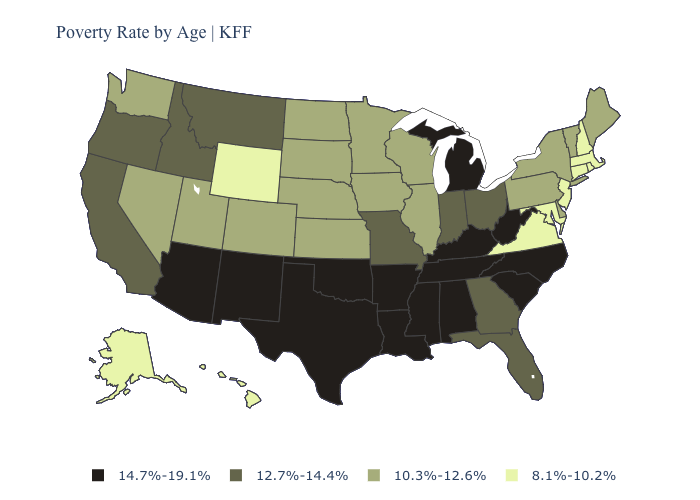Does Alaska have the highest value in the USA?
Be succinct. No. Name the states that have a value in the range 8.1%-10.2%?
Write a very short answer. Alaska, Connecticut, Hawaii, Maryland, Massachusetts, New Hampshire, New Jersey, Rhode Island, Virginia, Wyoming. Name the states that have a value in the range 8.1%-10.2%?
Write a very short answer. Alaska, Connecticut, Hawaii, Maryland, Massachusetts, New Hampshire, New Jersey, Rhode Island, Virginia, Wyoming. What is the highest value in the South ?
Give a very brief answer. 14.7%-19.1%. Does Wisconsin have a higher value than Arizona?
Short answer required. No. What is the value of Illinois?
Keep it brief. 10.3%-12.6%. Which states hav the highest value in the South?
Write a very short answer. Alabama, Arkansas, Kentucky, Louisiana, Mississippi, North Carolina, Oklahoma, South Carolina, Tennessee, Texas, West Virginia. Is the legend a continuous bar?
Be succinct. No. Does Hawaii have the same value as Maryland?
Concise answer only. Yes. Name the states that have a value in the range 8.1%-10.2%?
Give a very brief answer. Alaska, Connecticut, Hawaii, Maryland, Massachusetts, New Hampshire, New Jersey, Rhode Island, Virginia, Wyoming. What is the lowest value in the USA?
Be succinct. 8.1%-10.2%. Which states have the highest value in the USA?
Answer briefly. Alabama, Arizona, Arkansas, Kentucky, Louisiana, Michigan, Mississippi, New Mexico, North Carolina, Oklahoma, South Carolina, Tennessee, Texas, West Virginia. Name the states that have a value in the range 12.7%-14.4%?
Short answer required. California, Florida, Georgia, Idaho, Indiana, Missouri, Montana, Ohio, Oregon. What is the value of Idaho?
Keep it brief. 12.7%-14.4%. Among the states that border Oklahoma , which have the highest value?
Short answer required. Arkansas, New Mexico, Texas. 